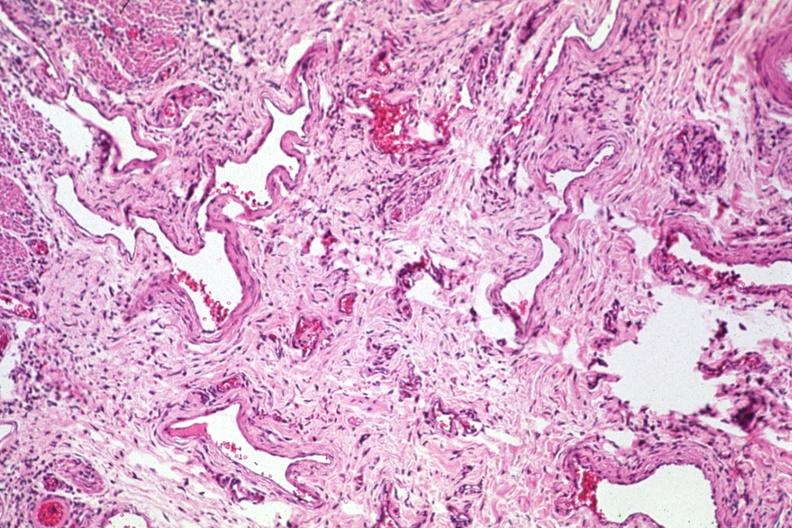what is present?
Answer the question using a single word or phrase. Varices 